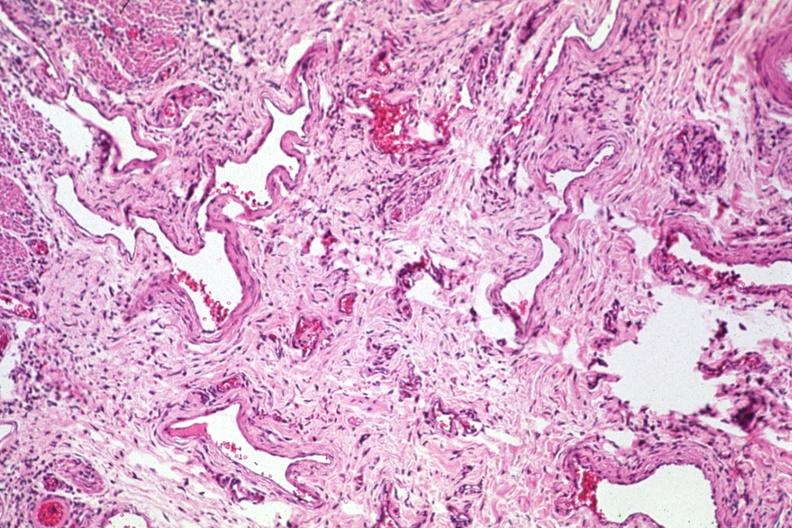what is present?
Answer the question using a single word or phrase. Varices 